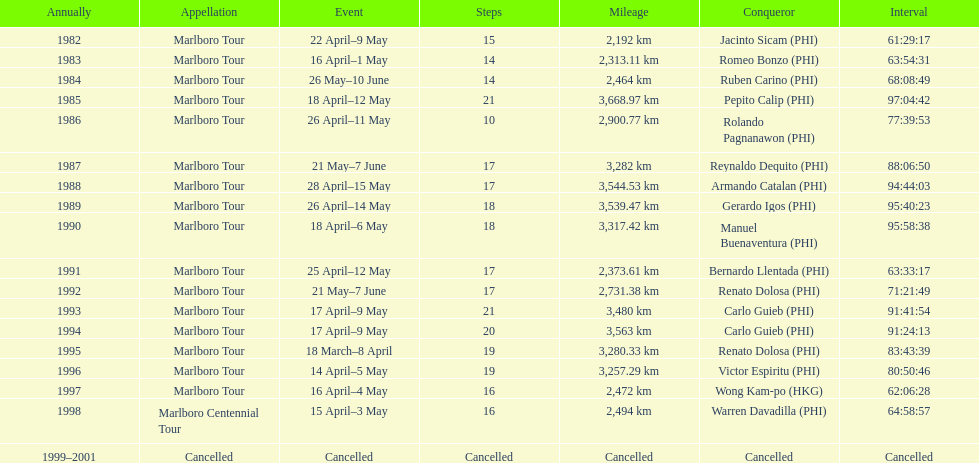Who was the only winner to have their time below 61:45:00? Jacinto Sicam. 